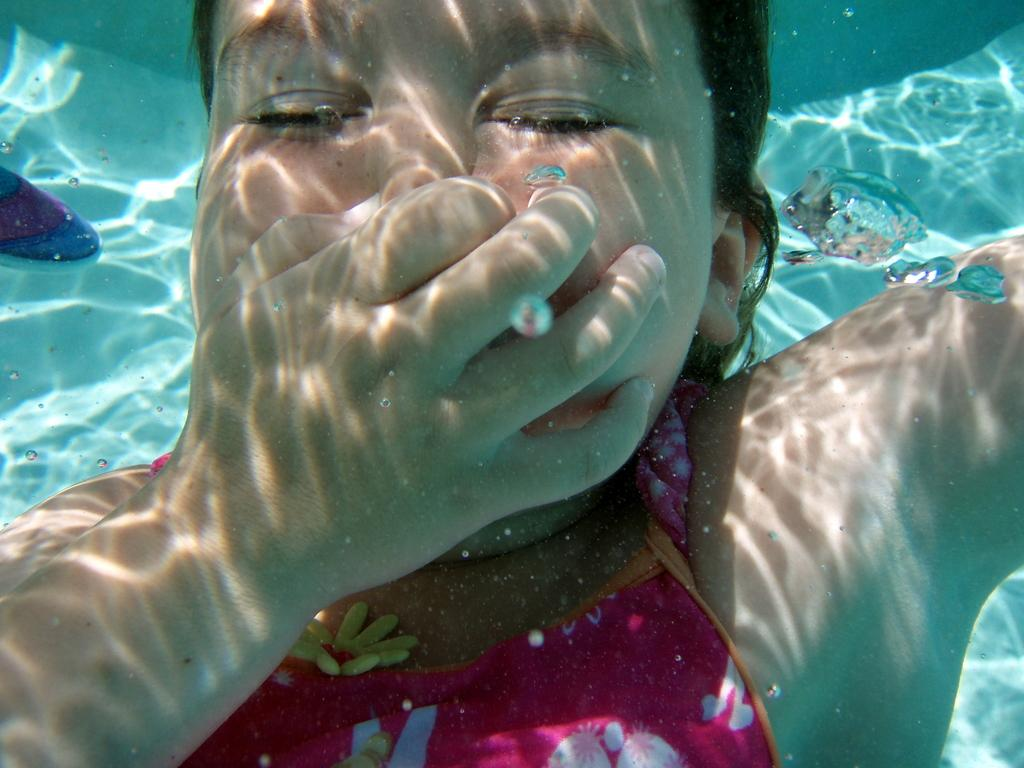What is partially visible in the image? There is a person, water, and a person's leg in the image, but they are all truncated. Can you describe the person in the image? The person in the image is truncated towards the bottom, so only a part of their body is visible. What is the nature of the water in the image? The water in the image is also truncated, so its extent is not fully visible. How is the person's leg positioned in the image? The person's leg is truncated towards the left, so only a part of it is visible. How many ants can be seen crawling on the leaf in the image? There is no leaf or ants present in the image. What type of cellar is visible in the image? There is no cellar present in the image. 